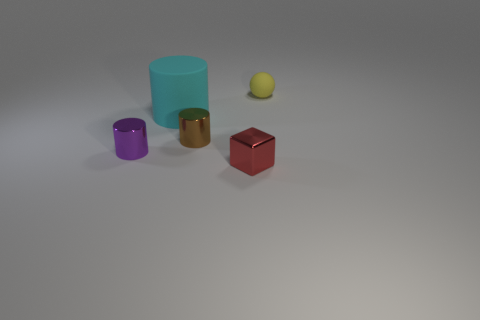What is the relative size of the purple cylinder to the green one? The purple cylinder is noticeably smaller and shorter than the green one. The green cylinder is larger in both height and diameter compared to the purple cylinder, indicating a significant size difference between the two objects. 